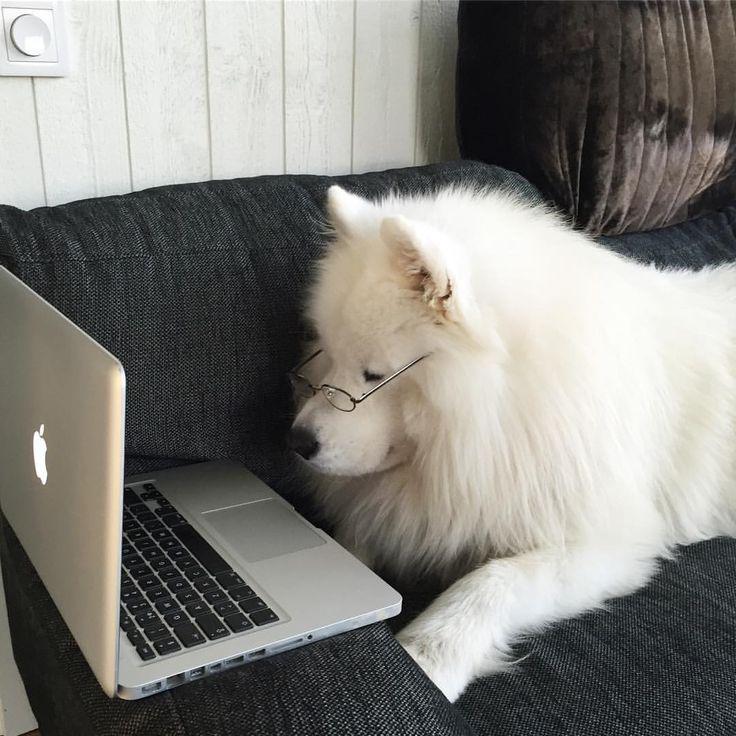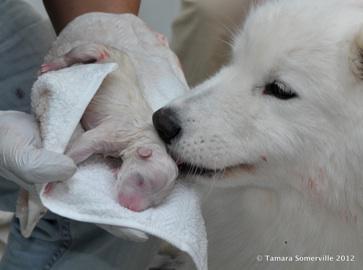The first image is the image on the left, the second image is the image on the right. For the images displayed, is the sentence "At least one of the images shows a single white dog." factually correct? Answer yes or no. Yes. 